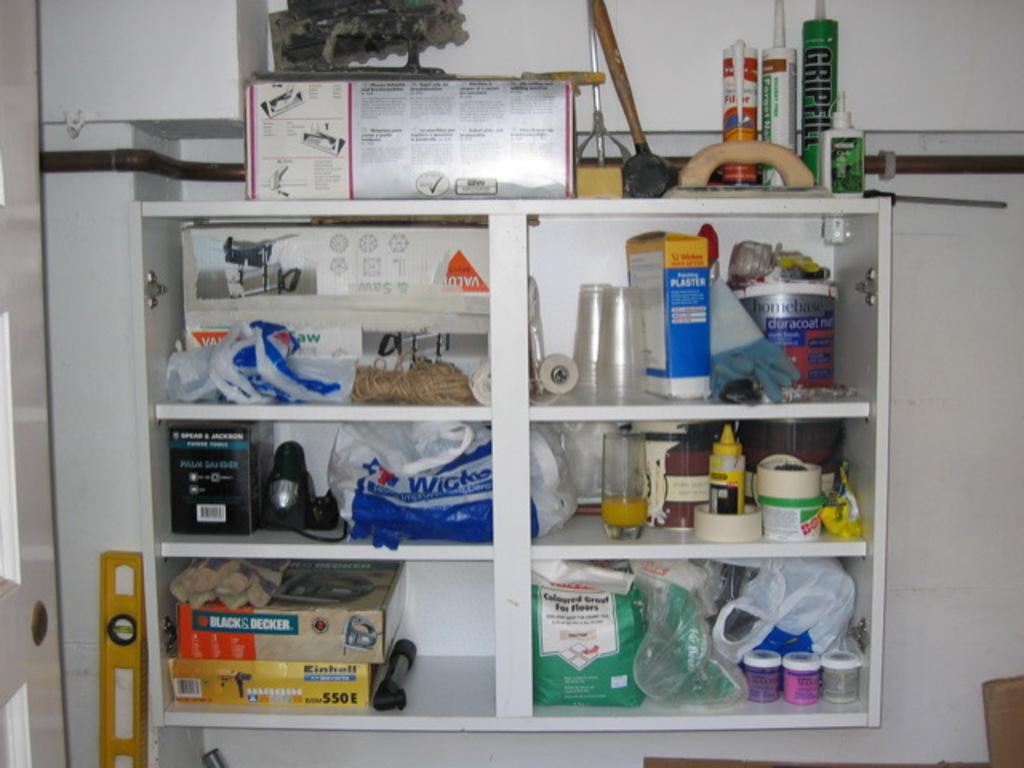Can you describe this image briefly? In the background of the image there is a wall. To which there is a shelf in which there are objects. 